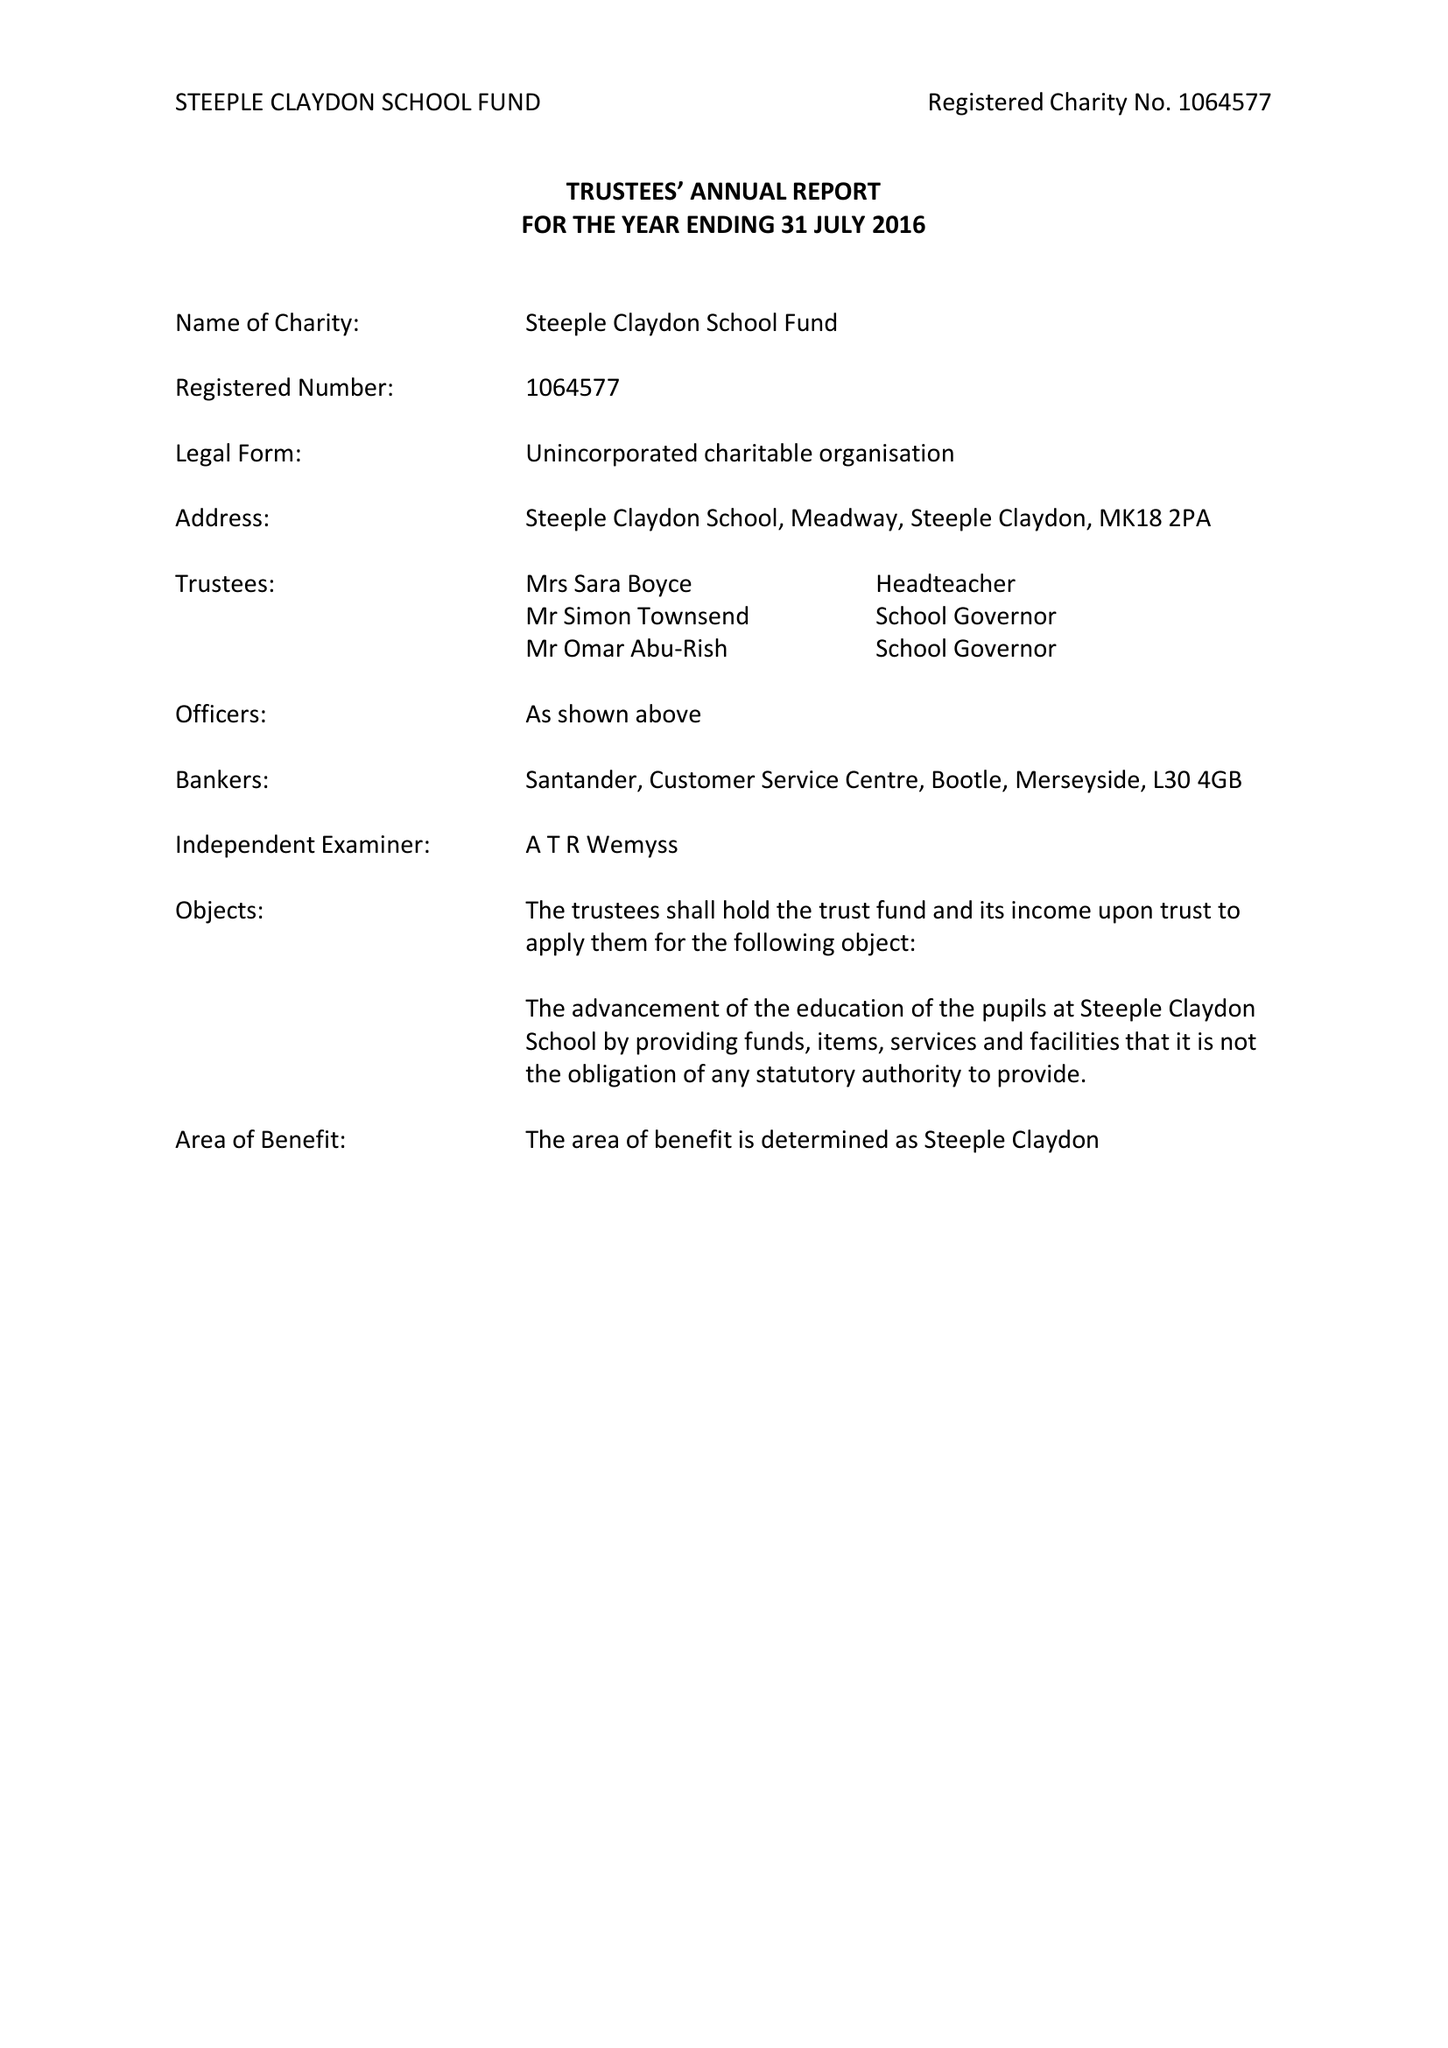What is the value for the address__street_line?
Answer the question using a single word or phrase. MEADOWAY 